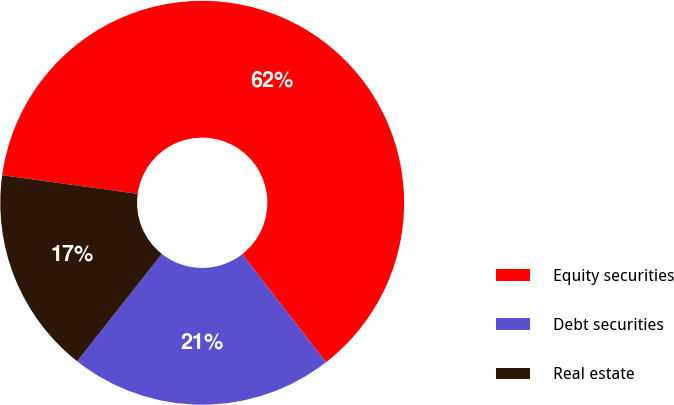Convert chart. <chart><loc_0><loc_0><loc_500><loc_500><pie_chart><fcel>Equity securities<fcel>Debt securities<fcel>Real estate<nl><fcel>62.32%<fcel>21.13%<fcel>16.55%<nl></chart> 